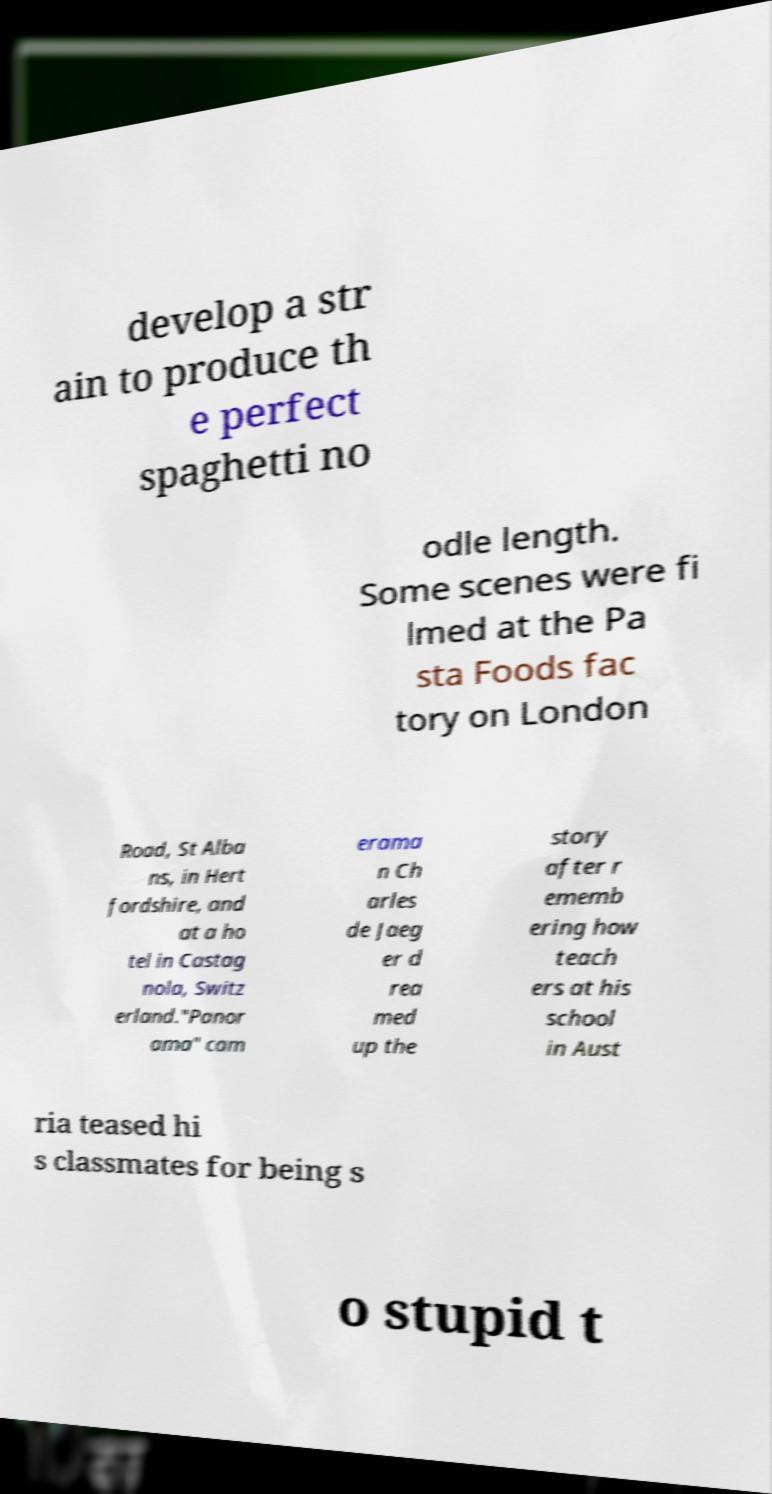Please identify and transcribe the text found in this image. develop a str ain to produce th e perfect spaghetti no odle length. Some scenes were fi lmed at the Pa sta Foods fac tory on London Road, St Alba ns, in Hert fordshire, and at a ho tel in Castag nola, Switz erland."Panor ama" cam erama n Ch arles de Jaeg er d rea med up the story after r ememb ering how teach ers at his school in Aust ria teased hi s classmates for being s o stupid t 